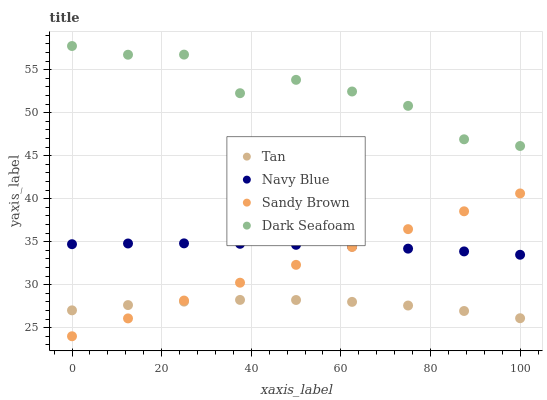Does Tan have the minimum area under the curve?
Answer yes or no. Yes. Does Dark Seafoam have the maximum area under the curve?
Answer yes or no. Yes. Does Sandy Brown have the minimum area under the curve?
Answer yes or no. No. Does Sandy Brown have the maximum area under the curve?
Answer yes or no. No. Is Sandy Brown the smoothest?
Answer yes or no. Yes. Is Dark Seafoam the roughest?
Answer yes or no. Yes. Is Tan the smoothest?
Answer yes or no. No. Is Tan the roughest?
Answer yes or no. No. Does Sandy Brown have the lowest value?
Answer yes or no. Yes. Does Tan have the lowest value?
Answer yes or no. No. Does Dark Seafoam have the highest value?
Answer yes or no. Yes. Does Sandy Brown have the highest value?
Answer yes or no. No. Is Navy Blue less than Dark Seafoam?
Answer yes or no. Yes. Is Dark Seafoam greater than Sandy Brown?
Answer yes or no. Yes. Does Tan intersect Sandy Brown?
Answer yes or no. Yes. Is Tan less than Sandy Brown?
Answer yes or no. No. Is Tan greater than Sandy Brown?
Answer yes or no. No. Does Navy Blue intersect Dark Seafoam?
Answer yes or no. No. 